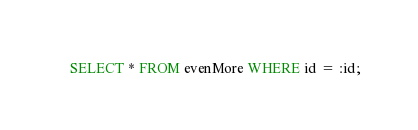<code> <loc_0><loc_0><loc_500><loc_500><_SQL_>SELECT * FROM evenMore WHERE id = :id;
</code> 